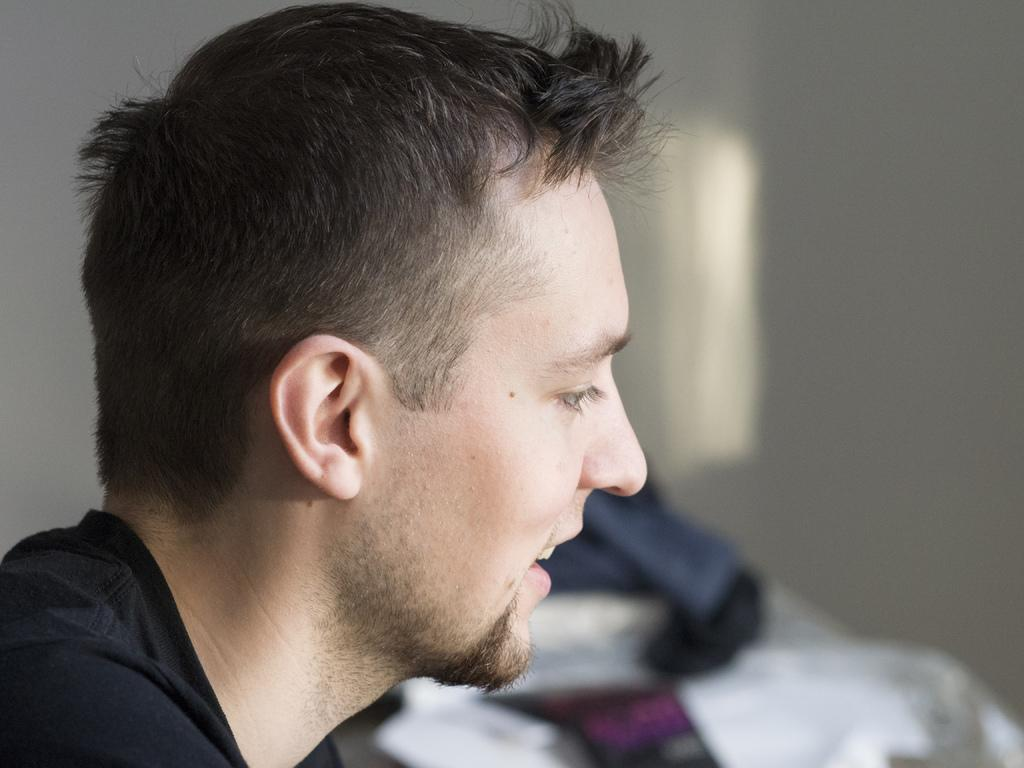Who is present in the image? There is a man in the image. What is the man's facial expression? The man is smiling. What can be seen in the background of the image? There is a wall and clothes in the background of the image. What song is the man singing in the image? There is no indication in the image that the man is singing a song, so it cannot be determined from the picture. 